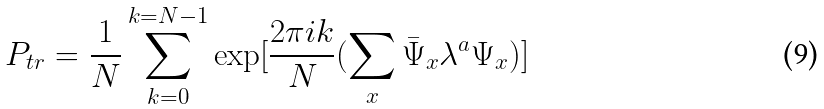Convert formula to latex. <formula><loc_0><loc_0><loc_500><loc_500>P _ { t r } = \frac { 1 } { N } \sum _ { k = 0 } ^ { k = N - 1 } \exp [ \frac { 2 \pi i k } { N } ( \sum _ { x } \bar { \Psi } _ { x } \lambda ^ { a } \Psi _ { x } ) ]</formula> 